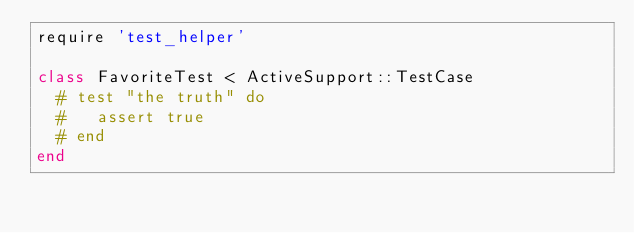<code> <loc_0><loc_0><loc_500><loc_500><_Ruby_>require 'test_helper'

class FavoriteTest < ActiveSupport::TestCase
  # test "the truth" do
  #   assert true
  # end
end
</code> 